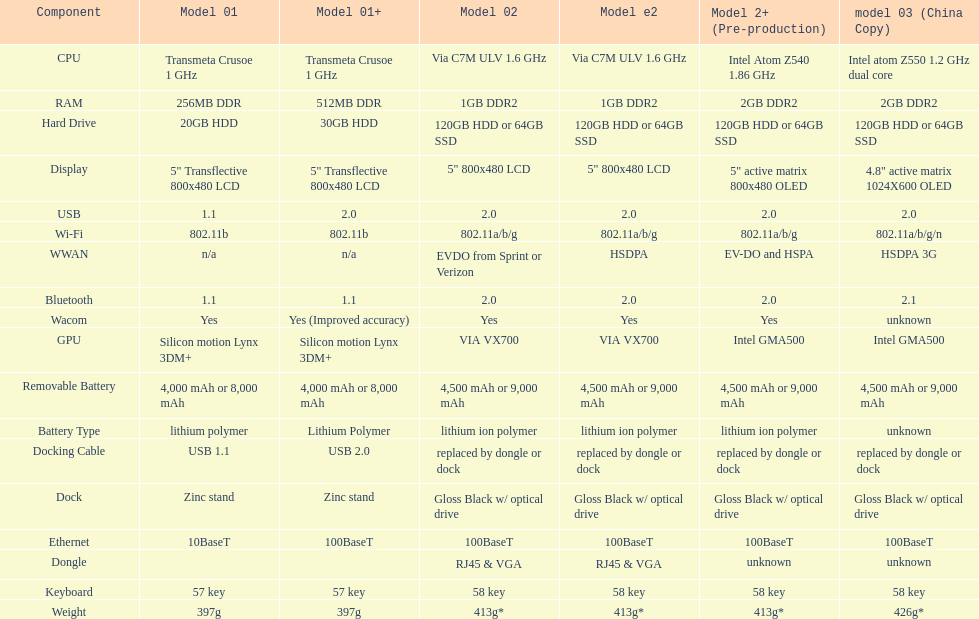How many models contain 2. 